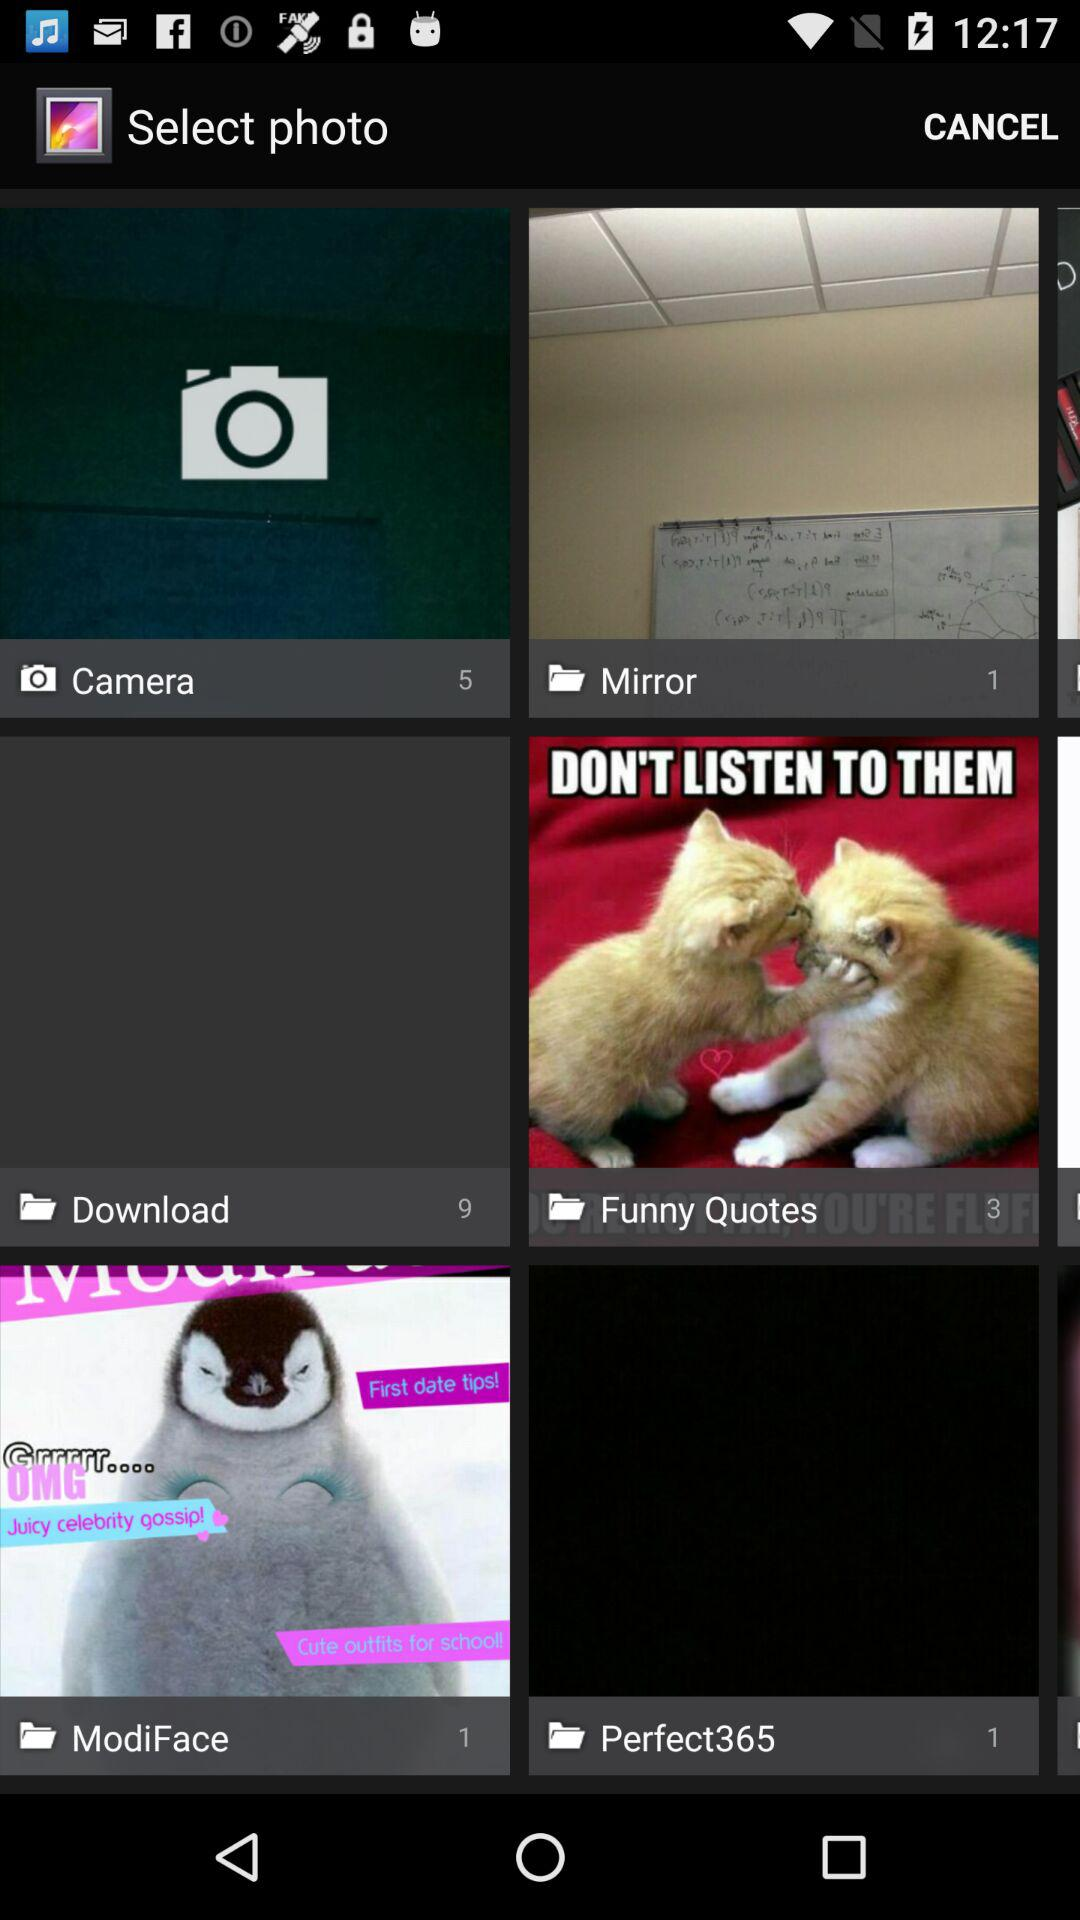Which folder has 5 pictures? The folder that has five pictures is Camera. 